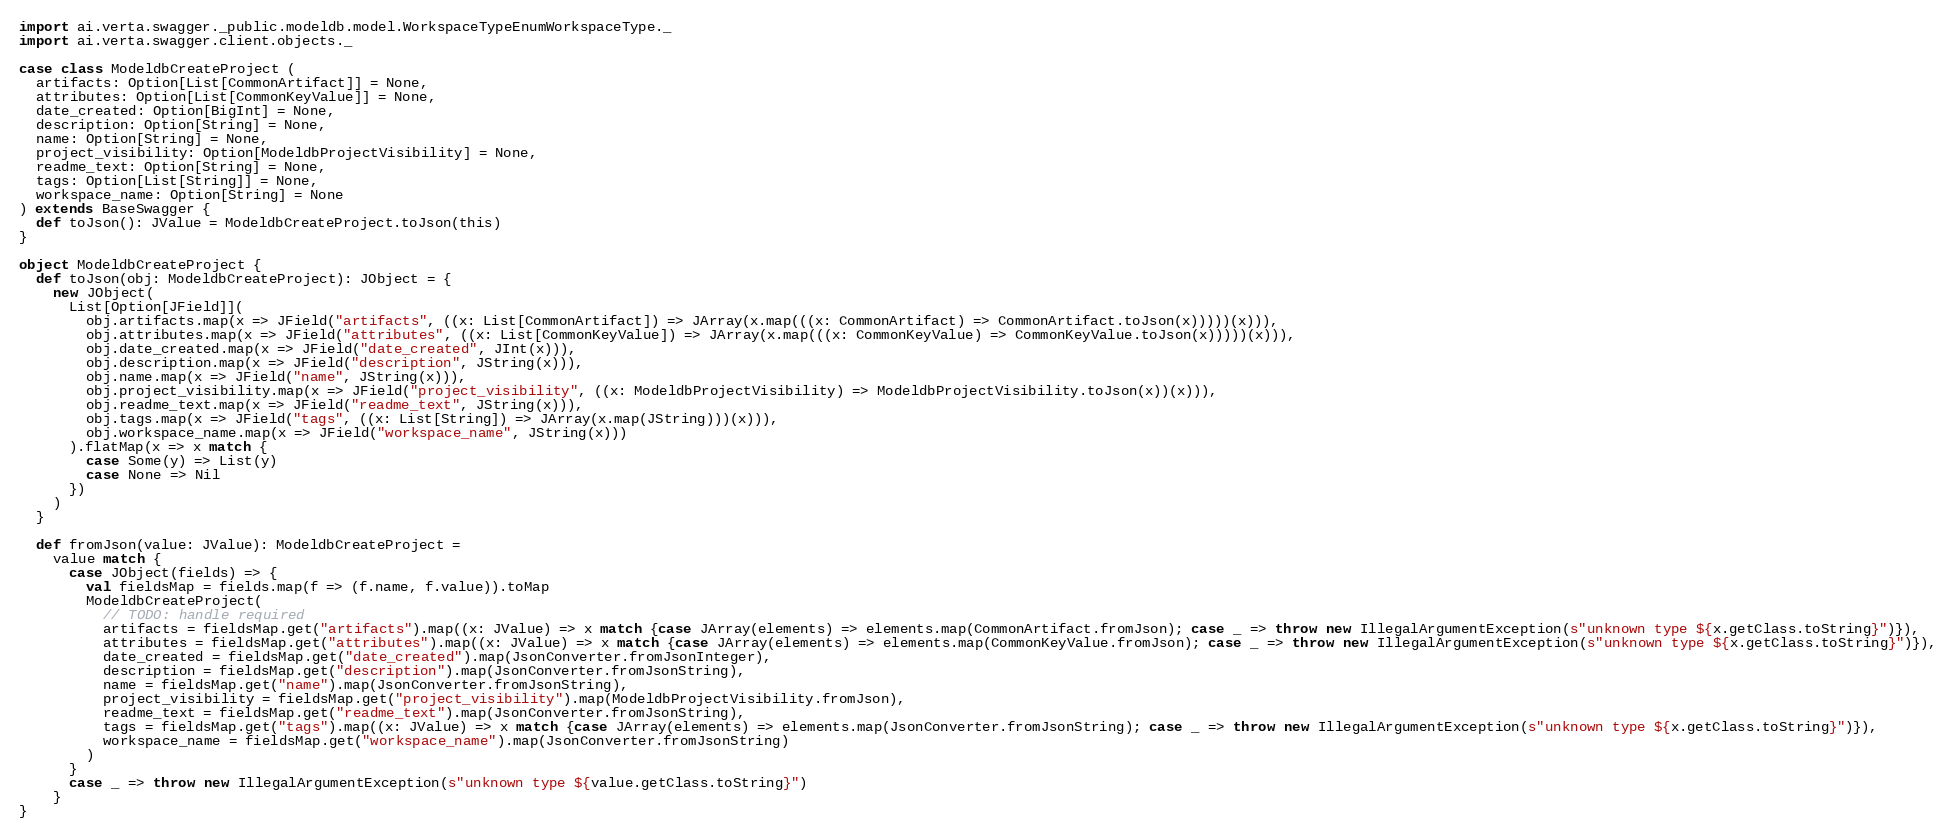Convert code to text. <code><loc_0><loc_0><loc_500><loc_500><_Scala_>import ai.verta.swagger._public.modeldb.model.WorkspaceTypeEnumWorkspaceType._
import ai.verta.swagger.client.objects._

case class ModeldbCreateProject (
  artifacts: Option[List[CommonArtifact]] = None,
  attributes: Option[List[CommonKeyValue]] = None,
  date_created: Option[BigInt] = None,
  description: Option[String] = None,
  name: Option[String] = None,
  project_visibility: Option[ModeldbProjectVisibility] = None,
  readme_text: Option[String] = None,
  tags: Option[List[String]] = None,
  workspace_name: Option[String] = None
) extends BaseSwagger {
  def toJson(): JValue = ModeldbCreateProject.toJson(this)
}

object ModeldbCreateProject {
  def toJson(obj: ModeldbCreateProject): JObject = {
    new JObject(
      List[Option[JField]](
        obj.artifacts.map(x => JField("artifacts", ((x: List[CommonArtifact]) => JArray(x.map(((x: CommonArtifact) => CommonArtifact.toJson(x)))))(x))),
        obj.attributes.map(x => JField("attributes", ((x: List[CommonKeyValue]) => JArray(x.map(((x: CommonKeyValue) => CommonKeyValue.toJson(x)))))(x))),
        obj.date_created.map(x => JField("date_created", JInt(x))),
        obj.description.map(x => JField("description", JString(x))),
        obj.name.map(x => JField("name", JString(x))),
        obj.project_visibility.map(x => JField("project_visibility", ((x: ModeldbProjectVisibility) => ModeldbProjectVisibility.toJson(x))(x))),
        obj.readme_text.map(x => JField("readme_text", JString(x))),
        obj.tags.map(x => JField("tags", ((x: List[String]) => JArray(x.map(JString)))(x))),
        obj.workspace_name.map(x => JField("workspace_name", JString(x)))
      ).flatMap(x => x match {
        case Some(y) => List(y)
        case None => Nil
      })
    )
  }

  def fromJson(value: JValue): ModeldbCreateProject =
    value match {
      case JObject(fields) => {
        val fieldsMap = fields.map(f => (f.name, f.value)).toMap
        ModeldbCreateProject(
          // TODO: handle required
          artifacts = fieldsMap.get("artifacts").map((x: JValue) => x match {case JArray(elements) => elements.map(CommonArtifact.fromJson); case _ => throw new IllegalArgumentException(s"unknown type ${x.getClass.toString}")}),
          attributes = fieldsMap.get("attributes").map((x: JValue) => x match {case JArray(elements) => elements.map(CommonKeyValue.fromJson); case _ => throw new IllegalArgumentException(s"unknown type ${x.getClass.toString}")}),
          date_created = fieldsMap.get("date_created").map(JsonConverter.fromJsonInteger),
          description = fieldsMap.get("description").map(JsonConverter.fromJsonString),
          name = fieldsMap.get("name").map(JsonConverter.fromJsonString),
          project_visibility = fieldsMap.get("project_visibility").map(ModeldbProjectVisibility.fromJson),
          readme_text = fieldsMap.get("readme_text").map(JsonConverter.fromJsonString),
          tags = fieldsMap.get("tags").map((x: JValue) => x match {case JArray(elements) => elements.map(JsonConverter.fromJsonString); case _ => throw new IllegalArgumentException(s"unknown type ${x.getClass.toString}")}),
          workspace_name = fieldsMap.get("workspace_name").map(JsonConverter.fromJsonString)
        )
      }
      case _ => throw new IllegalArgumentException(s"unknown type ${value.getClass.toString}")
    }
}
</code> 